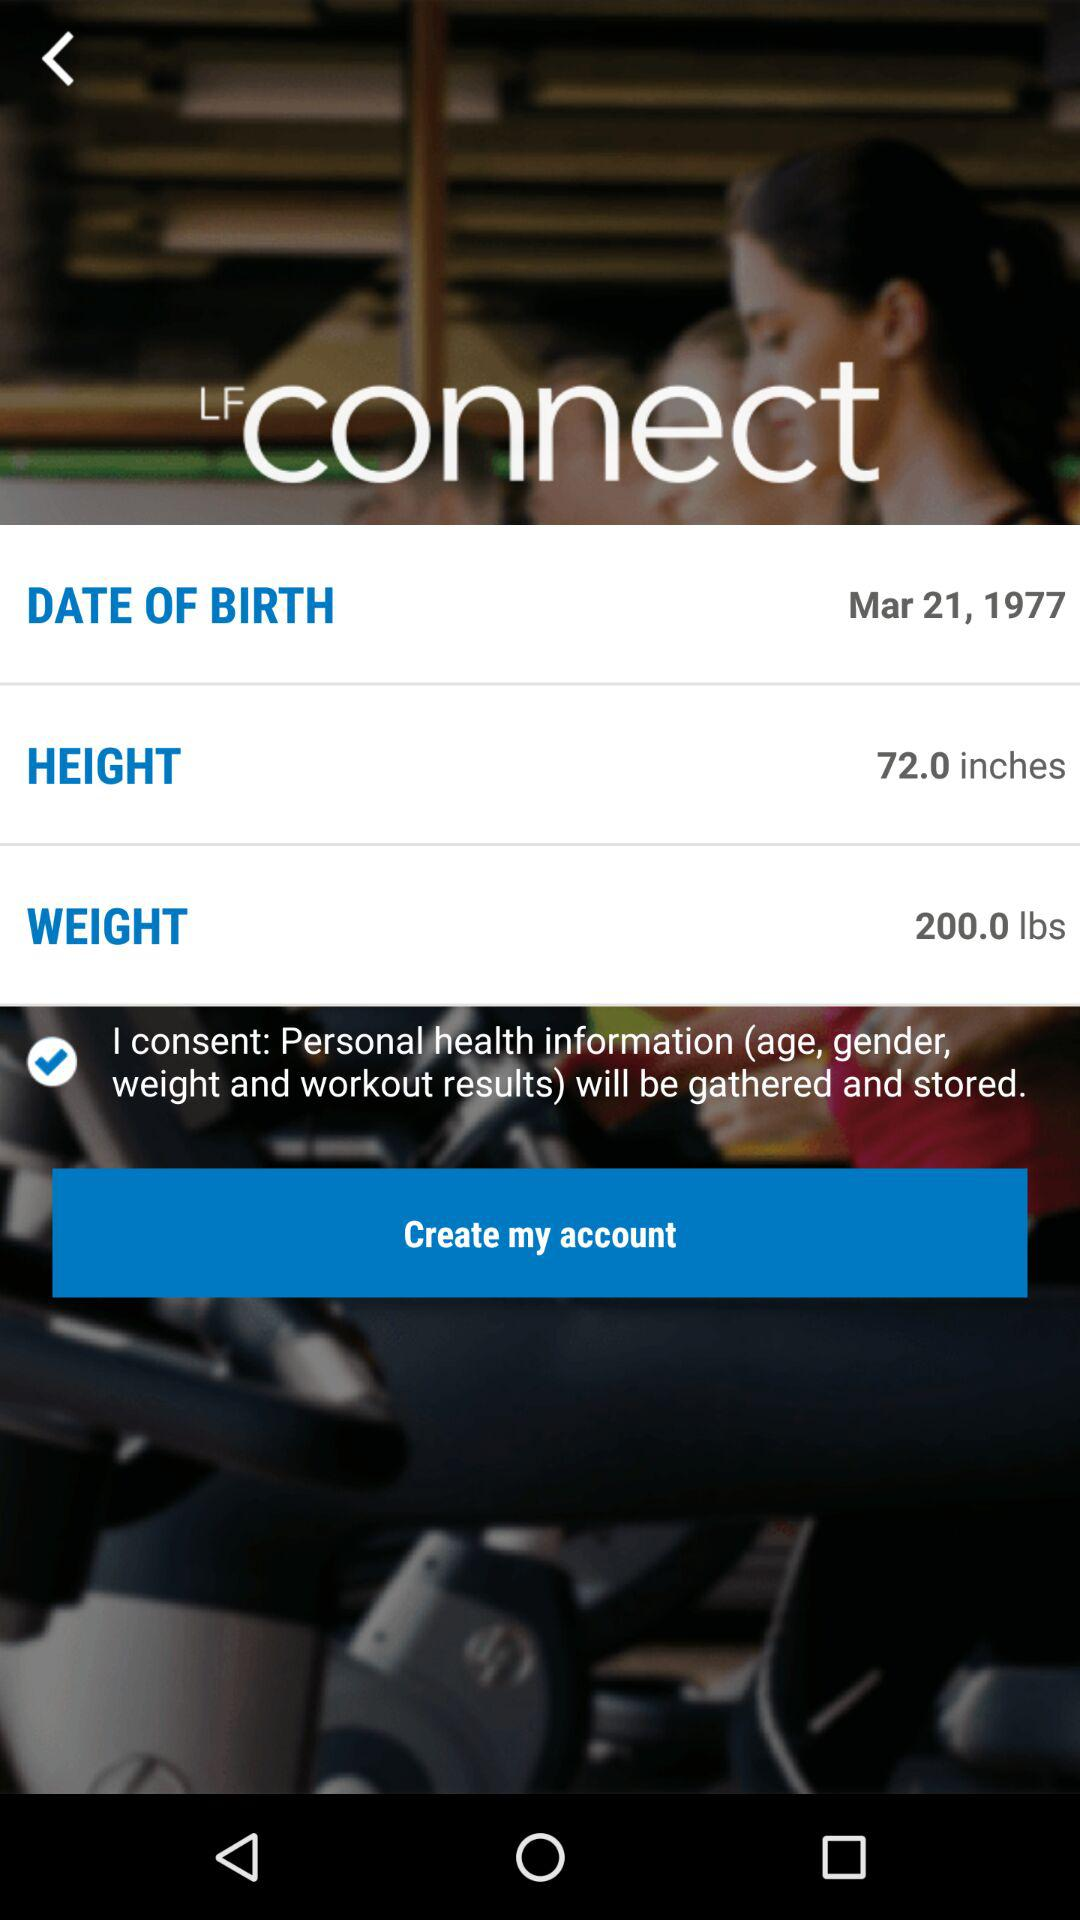What personal health information will be gathered and stored? Personal health information about age, gender, weight and workout results will be gathered and stored. 